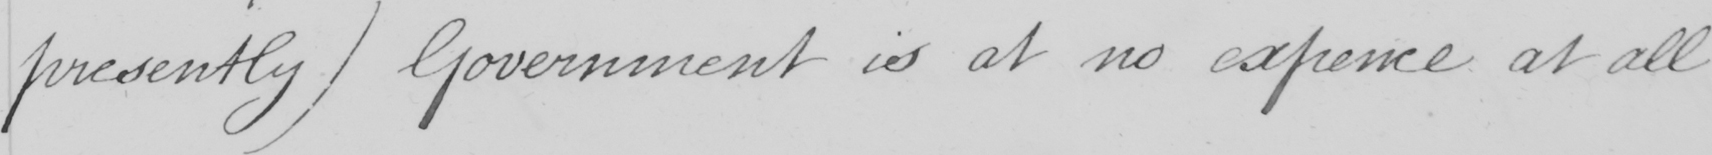Can you read and transcribe this handwriting? presently )  Government is at no expence at all 